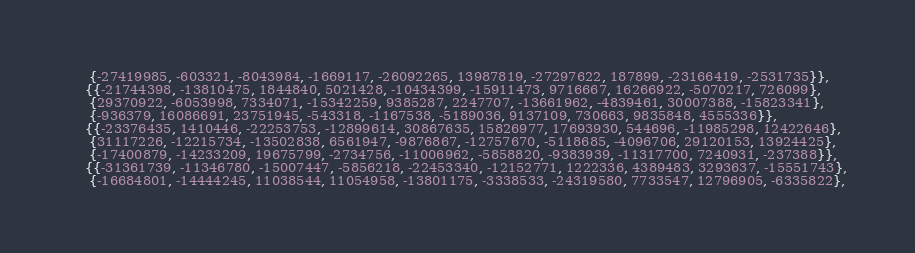<code> <loc_0><loc_0><loc_500><loc_500><_C_>     {-27419985, -603321, -8043984, -1669117, -26092265, 13987819, -27297622, 187899, -23166419, -2531735}},
    {{-21744398, -13810475, 1844840, 5021428, -10434399, -15911473, 9716667, 16266922, -5070217, 726099},
     {29370922, -6053998, 7334071, -15342259, 9385287, 2247707, -13661962, -4839461, 30007388, -15823341},
     {-936379, 16086691, 23751945, -543318, -1167538, -5189036, 9137109, 730663, 9835848, 4555336}},
    {{-23376435, 1410446, -22253753, -12899614, 30867635, 15826977, 17693930, 544696, -11985298, 12422646},
     {31117226, -12215734, -13502838, 6561947, -9876867, -12757670, -5118685, -4096706, 29120153, 13924425},
     {-17400879, -14233209, 19675799, -2734756, -11006962, -5858820, -9383939, -11317700, 7240931, -237388}},
    {{-31361739, -11346780, -15007447, -5856218, -22453340, -12152771, 1222336, 4389483, 3293637, -15551743},
     {-16684801, -14444245, 11038544, 11054958, -13801175, -3338533, -24319580, 7733547, 12796905, -6335822},</code> 